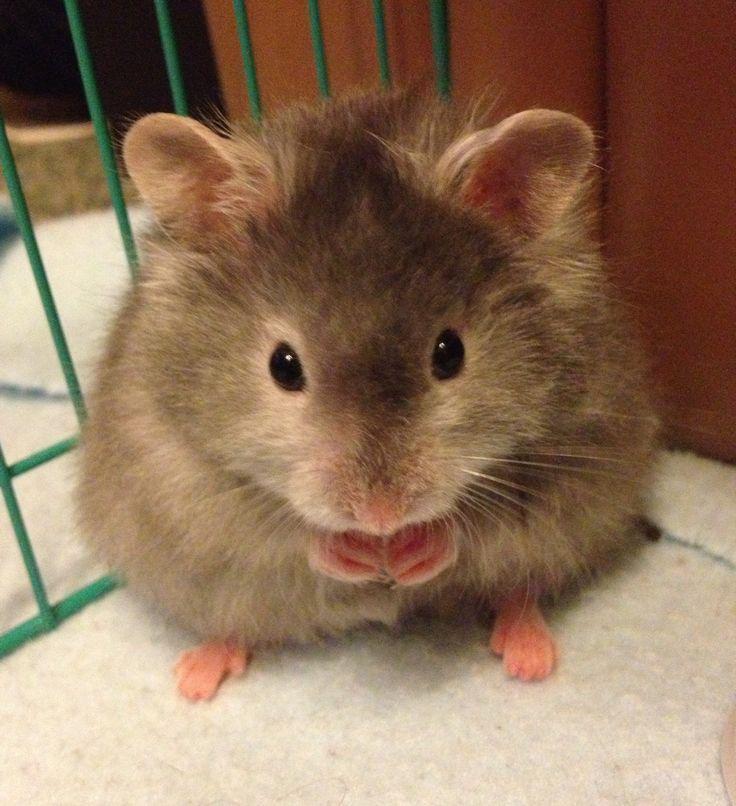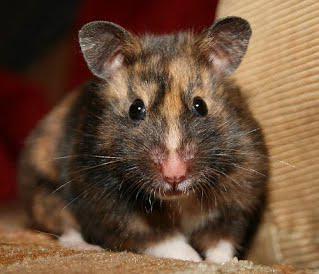The first image is the image on the left, the second image is the image on the right. Analyze the images presented: Is the assertion "One of the images features some of the hamster's food." valid? Answer yes or no. No. The first image is the image on the left, the second image is the image on the right. Given the left and right images, does the statement "Right image shows one pet rodent posed with both front paws off the ground in front of its chest." hold true? Answer yes or no. No. 